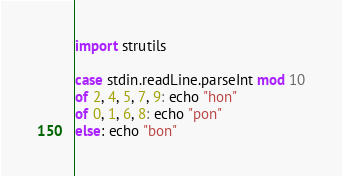<code> <loc_0><loc_0><loc_500><loc_500><_Nim_>import strutils

case stdin.readLine.parseInt mod 10
of 2, 4, 5, 7, 9: echo "hon"
of 0, 1, 6, 8: echo "pon"
else: echo "bon"</code> 